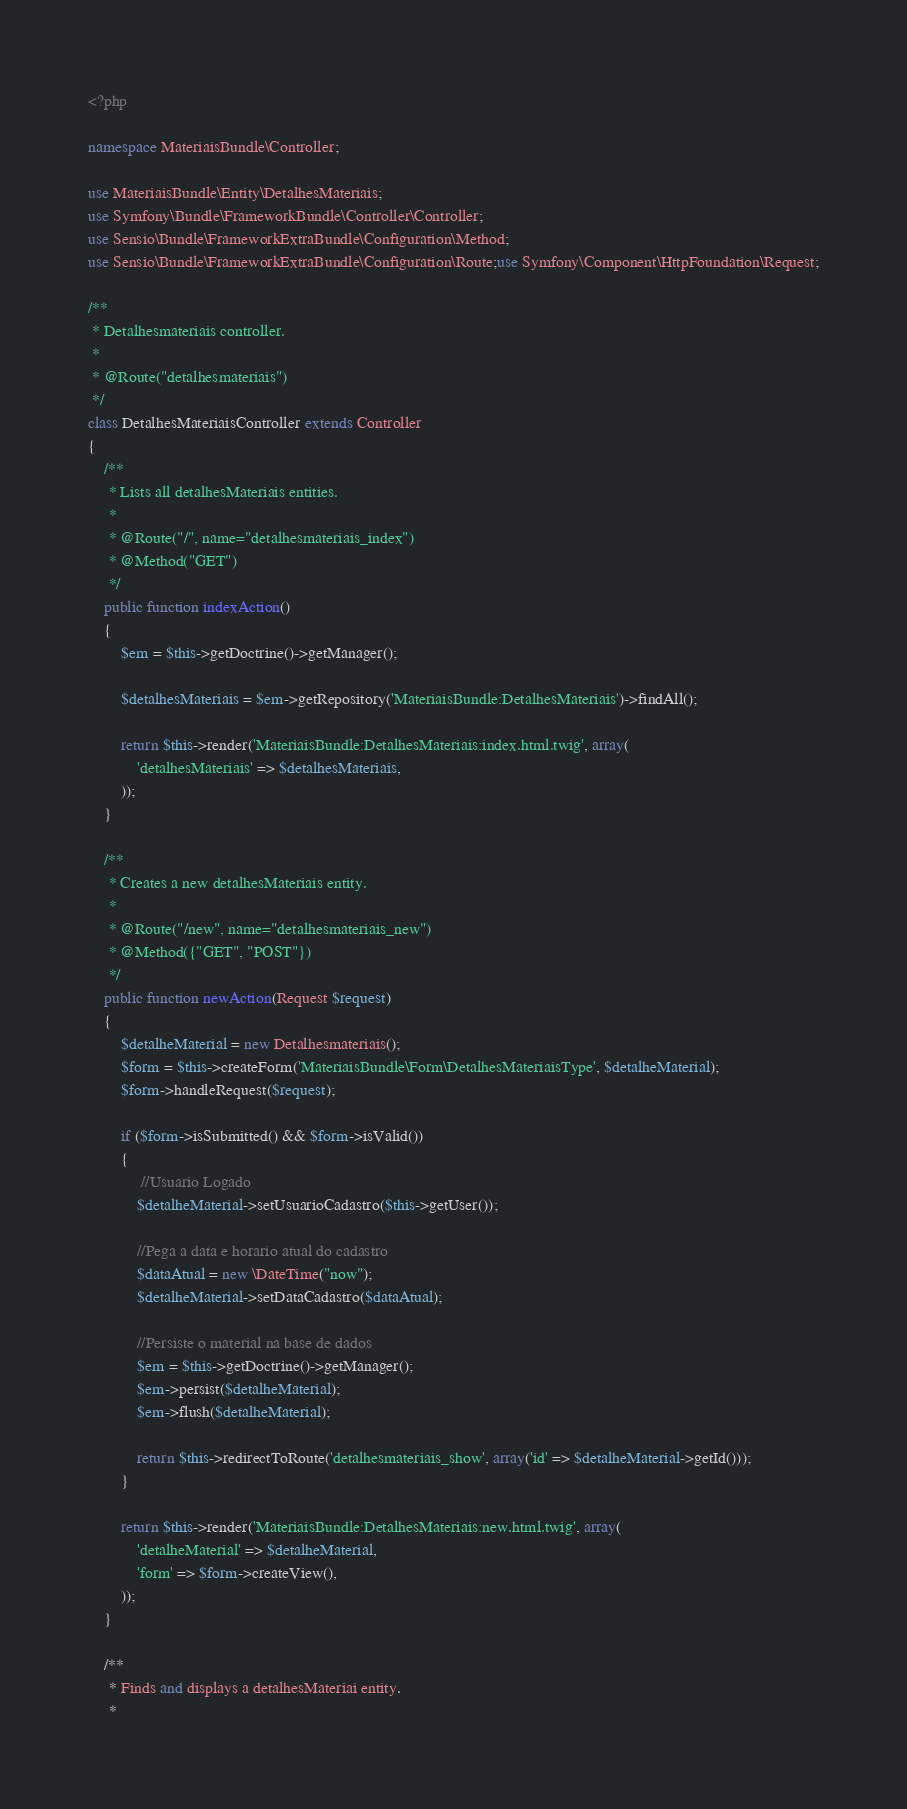Convert code to text. <code><loc_0><loc_0><loc_500><loc_500><_PHP_><?php

namespace MateriaisBundle\Controller;

use MateriaisBundle\Entity\DetalhesMateriais;
use Symfony\Bundle\FrameworkBundle\Controller\Controller;
use Sensio\Bundle\FrameworkExtraBundle\Configuration\Method;
use Sensio\Bundle\FrameworkExtraBundle\Configuration\Route;use Symfony\Component\HttpFoundation\Request;

/**
 * Detalhesmateriais controller.
 *
 * @Route("detalhesmateriais")
 */
class DetalhesMateriaisController extends Controller
{
    /**
     * Lists all detalhesMateriais entities.
     *
     * @Route("/", name="detalhesmateriais_index")
     * @Method("GET")
     */
    public function indexAction()
    {
        $em = $this->getDoctrine()->getManager();

        $detalhesMateriais = $em->getRepository('MateriaisBundle:DetalhesMateriais')->findAll();

        return $this->render('MateriaisBundle:DetalhesMateriais:index.html.twig', array(
            'detalhesMateriais' => $detalhesMateriais,
        ));
    }

    /**
     * Creates a new detalhesMateriais entity.
     *
     * @Route("/new", name="detalhesmateriais_new")
     * @Method({"GET", "POST"})
     */
    public function newAction(Request $request)
    {
        $detalheMaterial = new Detalhesmateriais();
        $form = $this->createForm('MateriaisBundle\Form\DetalhesMateriaisType', $detalheMaterial);
        $form->handleRequest($request);

        if ($form->isSubmitted() && $form->isValid()) 
        {
             //Usuario Logado
            $detalheMaterial->setUsuarioCadastro($this->getUser()); 
            
            //Pega a data e horario atual do cadastro
            $dataAtual = new \DateTime("now");
            $detalheMaterial->setDataCadastro($dataAtual); 
            
            //Persiste o material na base de dados
            $em = $this->getDoctrine()->getManager();
            $em->persist($detalheMaterial);
            $em->flush($detalheMaterial);

            return $this->redirectToRoute('detalhesmateriais_show', array('id' => $detalheMaterial->getId()));
        }

        return $this->render('MateriaisBundle:DetalhesMateriais:new.html.twig', array(
            'detalheMaterial' => $detalheMaterial,
            'form' => $form->createView(),
        ));
    }

    /**
     * Finds and displays a detalhesMateriai entity.
     *</code> 